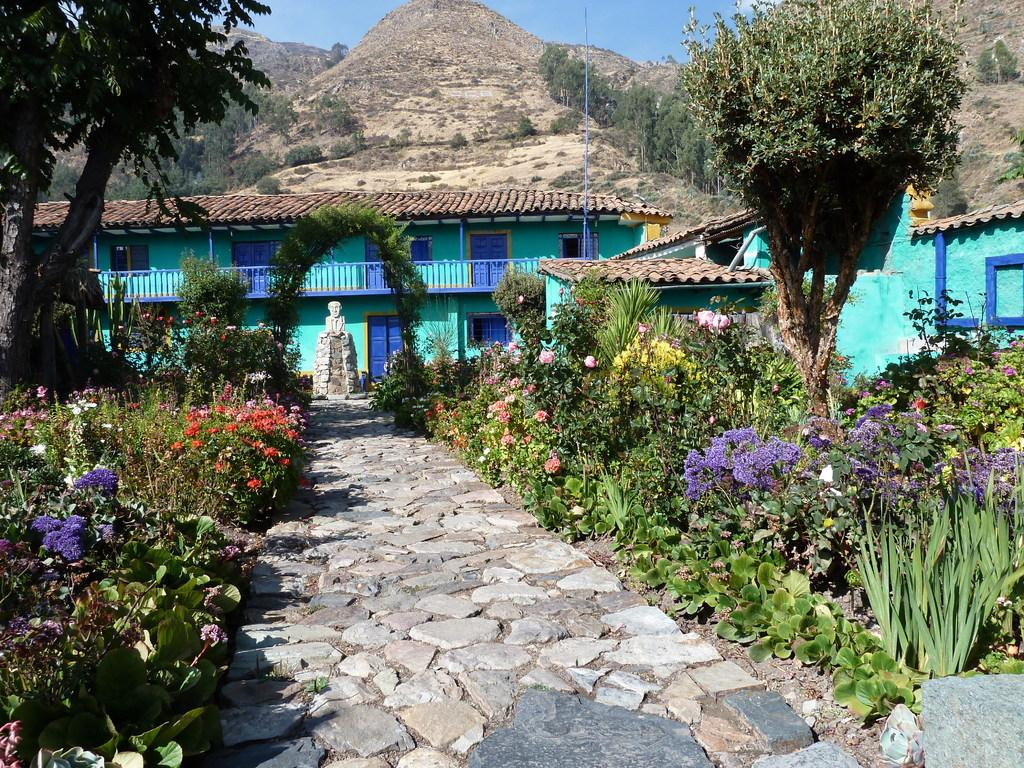What type of natural elements can be seen in the image? There are stones, trees, and plants with flowers in the image. What type of man-made structures are present in the image? There are buildings and a statue in the image. What is the geographical feature visible in the background of the image? There are mountains in the image. What is visible in the sky in the image? The sky is visible in the background of the image. Can you see a road in the image? There is no road visible in the image. 